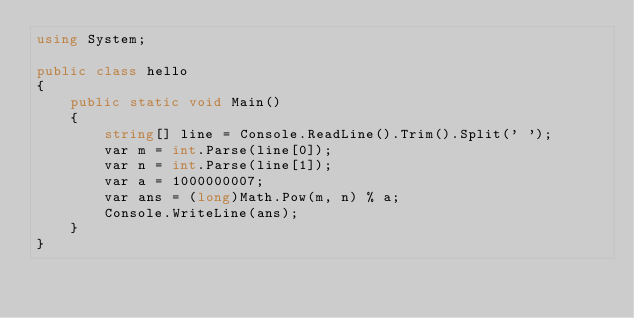<code> <loc_0><loc_0><loc_500><loc_500><_C#_>using System;

public class hello
{
    public static void Main()
    {
        string[] line = Console.ReadLine().Trim().Split(' ');
        var m = int.Parse(line[0]);
        var n = int.Parse(line[1]);
        var a = 1000000007;
        var ans = (long)Math.Pow(m, n) % a;
        Console.WriteLine(ans);
    }
}</code> 